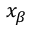Convert formula to latex. <formula><loc_0><loc_0><loc_500><loc_500>x _ { \beta }</formula> 